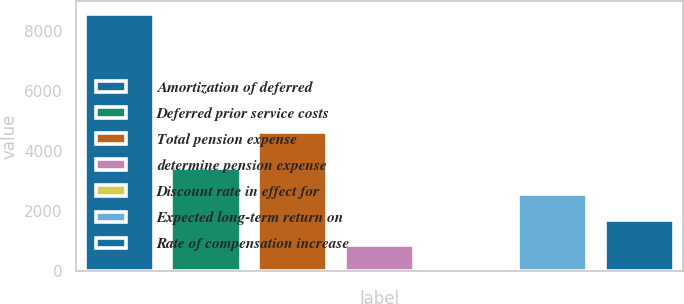<chart> <loc_0><loc_0><loc_500><loc_500><bar_chart><fcel>Amortization of deferred<fcel>Deferred prior service costs<fcel>Total pension expense<fcel>determine pension expense<fcel>Discount rate in effect for<fcel>Expected long-term return on<fcel>Rate of compensation increase<nl><fcel>8548<fcel>3421.09<fcel>4618<fcel>857.62<fcel>3.13<fcel>2566.6<fcel>1712.11<nl></chart> 